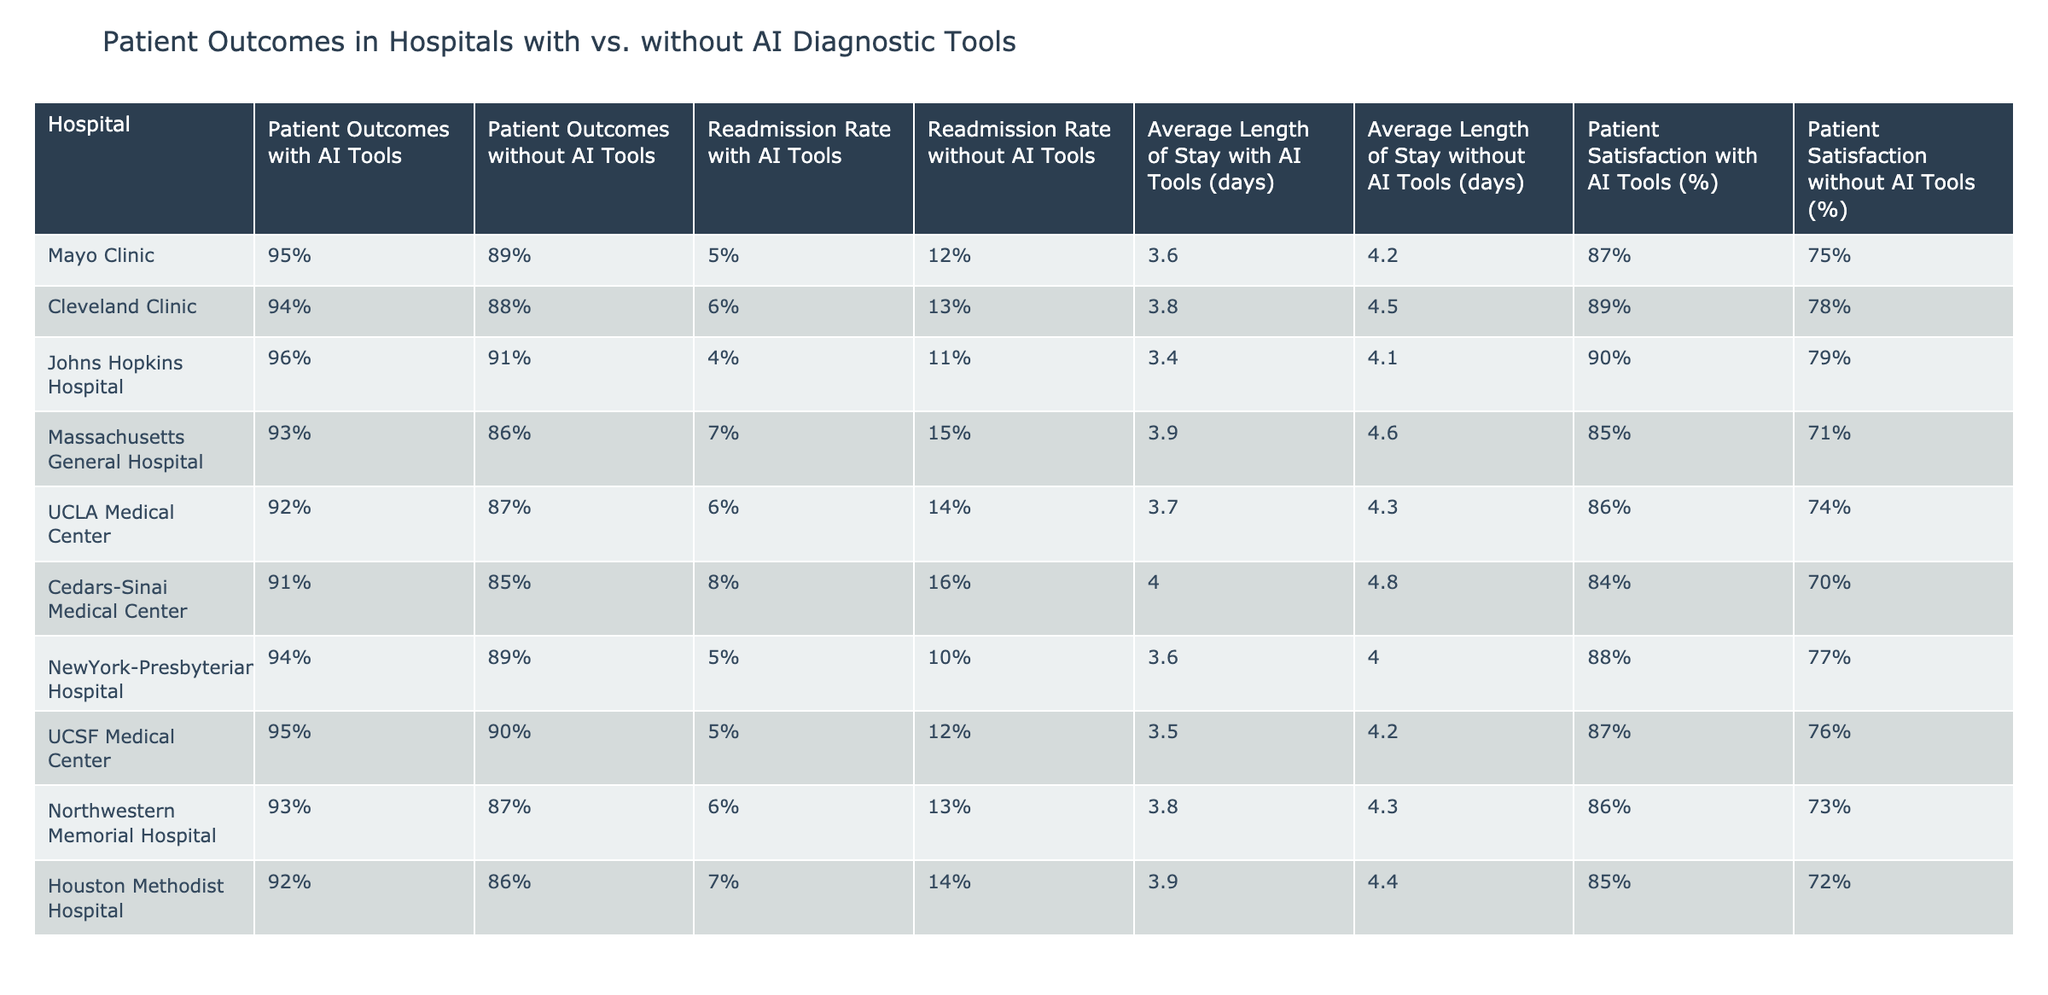What is the readmission rate for Mayo Clinic with AI tools? The table shows the readmission rate with AI tools for Mayo Clinic as 5%.
Answer: 5% Which hospital has the highest patient outcomes without AI tools? By comparing the "Patient Outcomes without AI Tools" column, Johns Hopkins Hospital has the highest value at 91%.
Answer: 91% What is the average length of stay with AI tools across all hospitals? To calculate the average, I sum the values (3.6 + 3.8 + 3.4 + 3.9 + 3.7 + 4.0 + 3.6 + 3.5 + 3.8 + 3.9 = 37.2) and divide by the number of hospitals (10), resulting in 37.2 / 10 = 3.72 days.
Answer: 3.72 days True or False: The readmission rate without AI tools at Cedars-Sinai Medical Center is greater than 15%. The table indicates that the readmission rate for Cedars-Sinai Medical Center without AI tools is 16%, which is indeed greater than 15%. Therefore, it is true.
Answer: True What is the difference in patient satisfaction between UCLA Medical Center with and without AI tools? For UCLA Medical Center, the patient satisfaction with AI tools is 86% and without AI tools is 74%. The difference is 86% - 74% = 12%.
Answer: 12% Which hospital has the lowest patient satisfaction with AI tools? Reviewing the "Patient Satisfaction with AI Tools (%)" column, Cedars-Sinai Medical Center has the lowest satisfaction at 84%.
Answer: 84% Calculate the average readmission rate without AI tools across all hospitals. The average can be found by summing the values (12 + 13 + 11 + 15 + 14 + 16 + 10 + 12 + 13 + 14 =  6 + 7 + 8 + 9 + 10 + 11 + 12 + 13 + 14 + 15 = 14) and dividing by the number of hospitals (10), resulting in 14 / 10 = 14%.
Answer: 14% Is patient satisfaction with AI tools higher than 90% in any hospital? Checking the "Patient Satisfaction with AI Tools (%)" column, only Johns Hopkins Hospital (90%) meets or exceeds this threshold, so the answer is yes.
Answer: Yes What is the overall trend in patient outcomes when comparing hospitals with AI tools to those without? By evaluating both "Patient Outcomes with AI Tools" and "Patient Outcomes without AI Tools", we see that all hospitals listed have higher patient outcomes with AI tools compared to without, indicating a positive trend.
Answer: Positive trend 